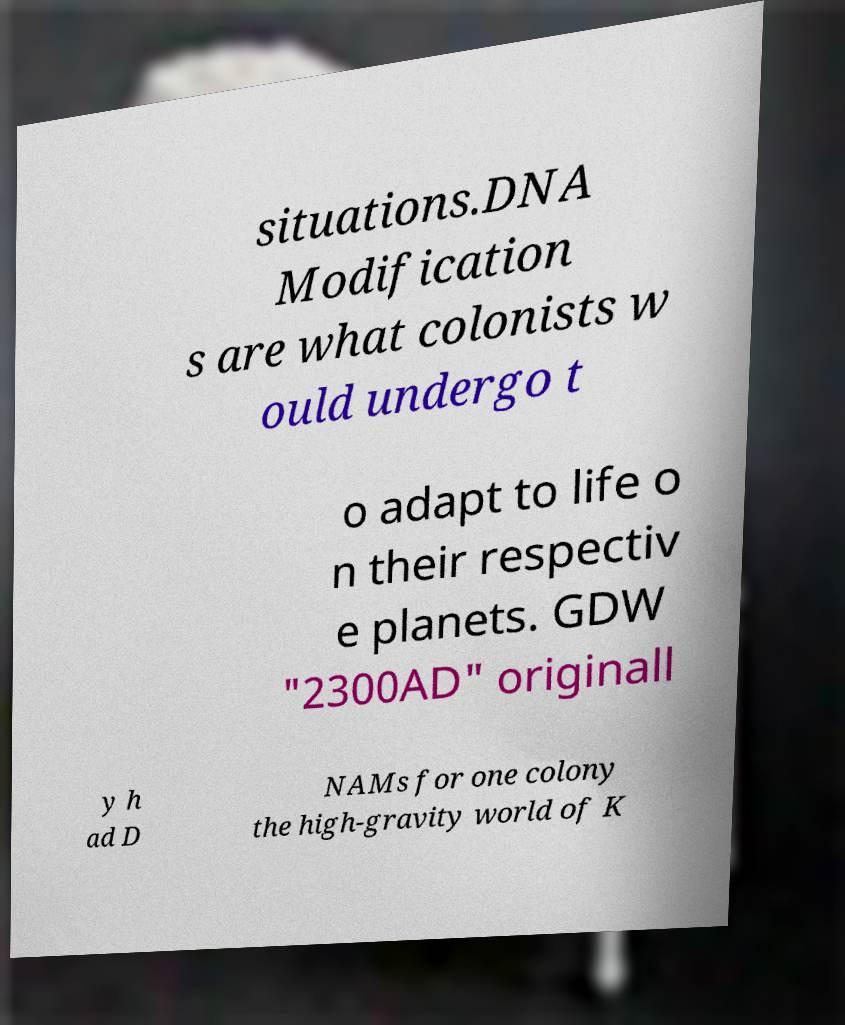Please read and relay the text visible in this image. What does it say? situations.DNA Modification s are what colonists w ould undergo t o adapt to life o n their respectiv e planets. GDW "2300AD" originall y h ad D NAMs for one colony the high-gravity world of K 